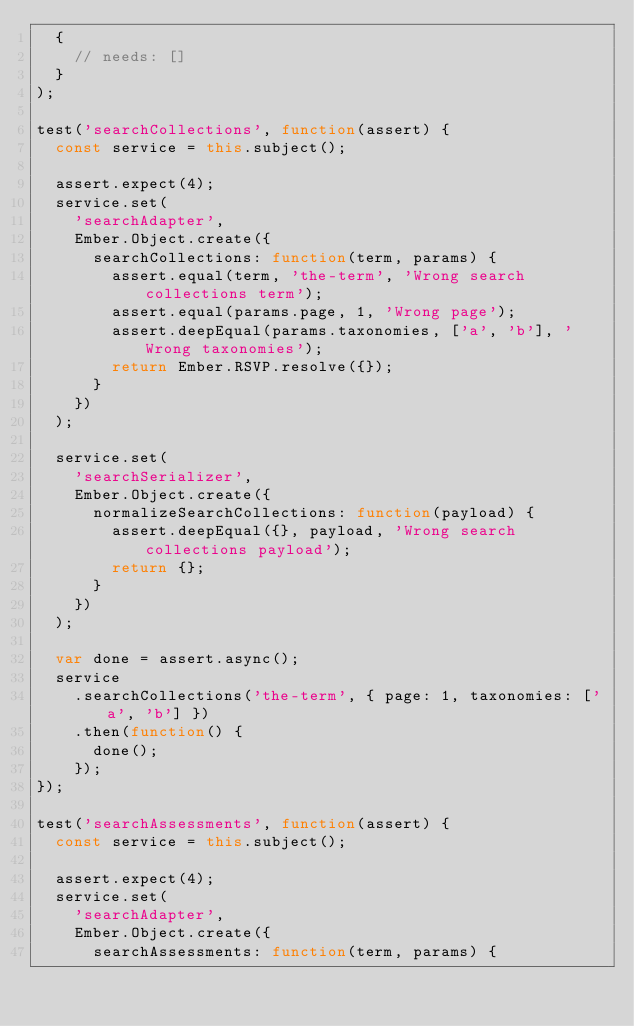<code> <loc_0><loc_0><loc_500><loc_500><_JavaScript_>  {
    // needs: []
  }
);

test('searchCollections', function(assert) {
  const service = this.subject();

  assert.expect(4);
  service.set(
    'searchAdapter',
    Ember.Object.create({
      searchCollections: function(term, params) {
        assert.equal(term, 'the-term', 'Wrong search collections term');
        assert.equal(params.page, 1, 'Wrong page');
        assert.deepEqual(params.taxonomies, ['a', 'b'], 'Wrong taxonomies');
        return Ember.RSVP.resolve({});
      }
    })
  );

  service.set(
    'searchSerializer',
    Ember.Object.create({
      normalizeSearchCollections: function(payload) {
        assert.deepEqual({}, payload, 'Wrong search collections payload');
        return {};
      }
    })
  );

  var done = assert.async();
  service
    .searchCollections('the-term', { page: 1, taxonomies: ['a', 'b'] })
    .then(function() {
      done();
    });
});

test('searchAssessments', function(assert) {
  const service = this.subject();

  assert.expect(4);
  service.set(
    'searchAdapter',
    Ember.Object.create({
      searchAssessments: function(term, params) {</code> 